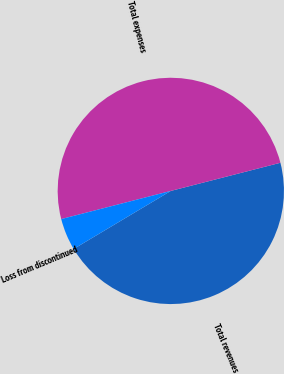<chart> <loc_0><loc_0><loc_500><loc_500><pie_chart><fcel>Total revenues<fcel>Total expenses<fcel>Loss from discontinued<nl><fcel>45.43%<fcel>50.0%<fcel>4.57%<nl></chart> 